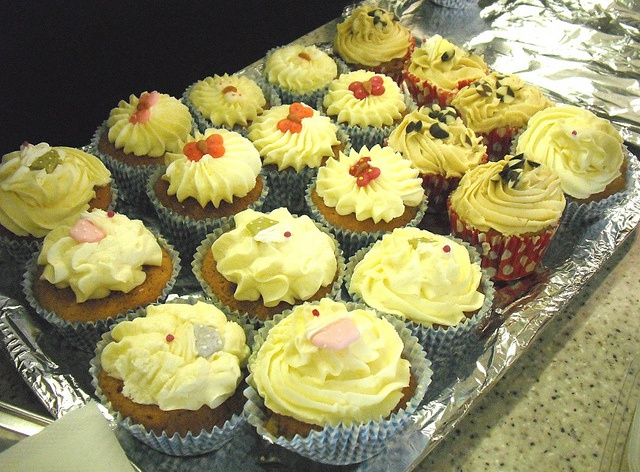Describe the objects in this image and their specific colors. I can see cake in black, khaki, and olive tones, dining table in black, tan, gray, and darkgreen tones, cake in black, khaki, and olive tones, cake in black, khaki, olive, and tan tones, and cake in black, khaki, olive, and tan tones in this image. 